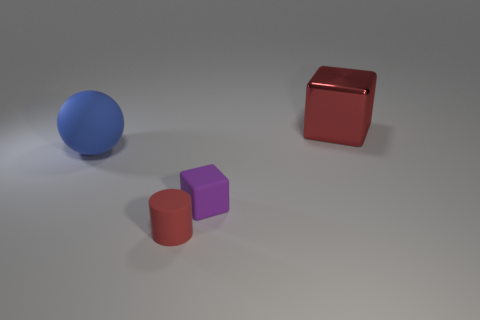What number of large red shiny things have the same shape as the tiny purple rubber thing?
Your answer should be compact. 1. There is a thing that is the same color as the big shiny cube; what material is it?
Provide a short and direct response. Rubber. Are the small purple object and the big red cube made of the same material?
Offer a very short reply. No. There is a red object that is behind the block in front of the metal cube; how many cubes are in front of it?
Keep it short and to the point. 1. Are there any other large balls made of the same material as the ball?
Your response must be concise. No. What is the size of the metallic block that is the same color as the cylinder?
Give a very brief answer. Large. Are there fewer big gray blocks than big blue objects?
Give a very brief answer. Yes. Is the color of the thing behind the ball the same as the rubber cylinder?
Offer a terse response. Yes. What is the material of the thing left of the red object in front of the cube behind the big blue object?
Your answer should be compact. Rubber. Is there a shiny object of the same color as the matte cylinder?
Provide a short and direct response. Yes. 